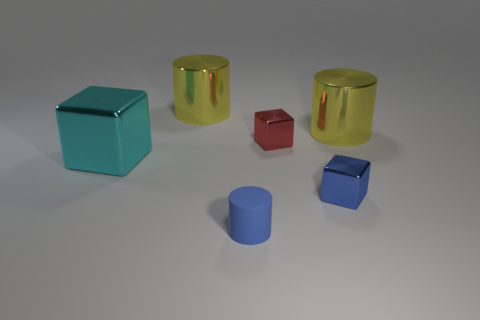Are there any other things that are the same material as the tiny cylinder?
Your response must be concise. No. Is there anything else that is the same color as the tiny rubber object?
Your answer should be very brief. Yes. How many metal things are big blocks or small yellow objects?
Make the answer very short. 1. There is a small red thing that is the same material as the big cyan object; what shape is it?
Offer a very short reply. Cube. What number of large yellow objects are the same shape as the blue matte object?
Your answer should be very brief. 2. Does the small shiny thing that is behind the big cyan metal block have the same shape as the small blue object in front of the tiny blue block?
Your response must be concise. No. What number of objects are either red metallic blocks or big yellow shiny things to the left of the red cube?
Offer a very short reply. 2. The tiny object that is the same color as the small matte cylinder is what shape?
Your answer should be very brief. Cube. What number of cylinders have the same size as the cyan metallic block?
Your response must be concise. 2. What number of red objects are matte things or small metallic things?
Your answer should be compact. 1. 